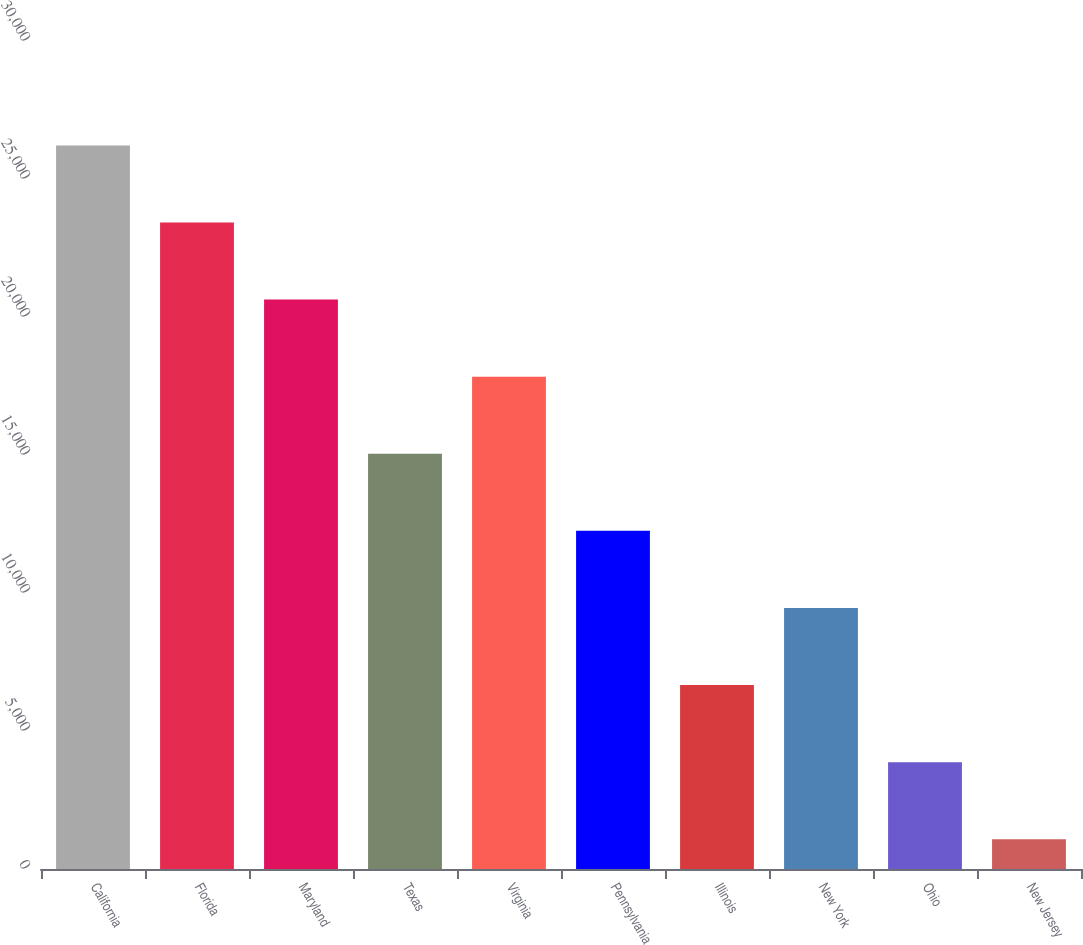<chart> <loc_0><loc_0><loc_500><loc_500><bar_chart><fcel>California<fcel>Florida<fcel>Maryland<fcel>Texas<fcel>Virginia<fcel>Pennsylvania<fcel>Illinois<fcel>New York<fcel>Ohio<fcel>New Jersey<nl><fcel>26216.9<fcel>23423.8<fcel>20630.7<fcel>15044.5<fcel>17837.6<fcel>12251.4<fcel>6665.2<fcel>9458.3<fcel>3872.1<fcel>1079<nl></chart> 